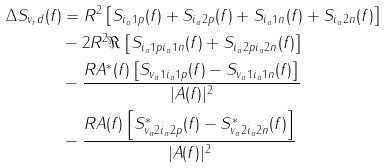<formula> <loc_0><loc_0><loc_500><loc_500>\Delta S _ { v _ { r } d } ( f ) & = R ^ { 2 } \left [ S _ { i _ { a } 1 p } ( f ) + S _ { i _ { a } 2 p } ( f ) + S _ { i _ { a } 1 n } ( f ) + S _ { i _ { a } 2 n } ( f ) \right ] \\ & - 2 R ^ { 2 } \Re \left [ S _ { i _ { a } 1 p i _ { a } 1 n } ( f ) + S _ { i _ { a } 2 p i _ { a } 2 n } ( f ) \right ] \\ & - \frac { R A ^ { * } ( f ) \left [ S _ { v _ { a } 1 i _ { a } 1 p } ( f ) - S _ { v _ { a } 1 i _ { a } 1 n } ( f ) \right ] } { | A ( f ) | ^ { 2 } } \\ & - \frac { R A ( f ) \left [ S ^ { * } _ { v _ { a } 2 i _ { a } 2 p } ( f ) - S ^ { * } _ { v _ { a } 2 i _ { a } 2 n } ( f ) \right ] } { | A ( f ) | ^ { 2 } }</formula> 